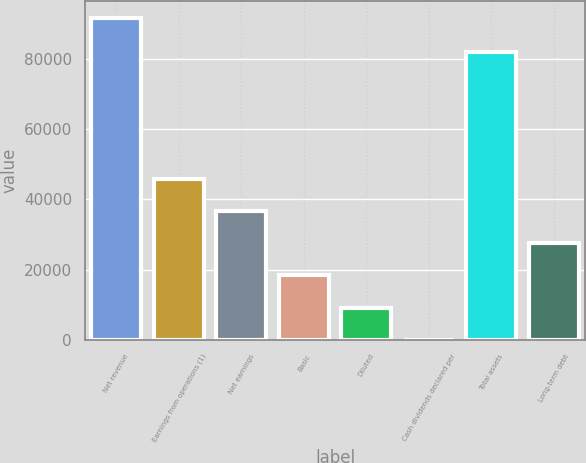<chart> <loc_0><loc_0><loc_500><loc_500><bar_chart><fcel>Net revenue<fcel>Earnings from operations (1)<fcel>Net earnings<fcel>Basic<fcel>Diluted<fcel>Cash dividends declared per<fcel>Total assets<fcel>Long-term debt<nl><fcel>91658<fcel>45829.2<fcel>36663.4<fcel>18331.9<fcel>9166.09<fcel>0.32<fcel>81981<fcel>27497.6<nl></chart> 